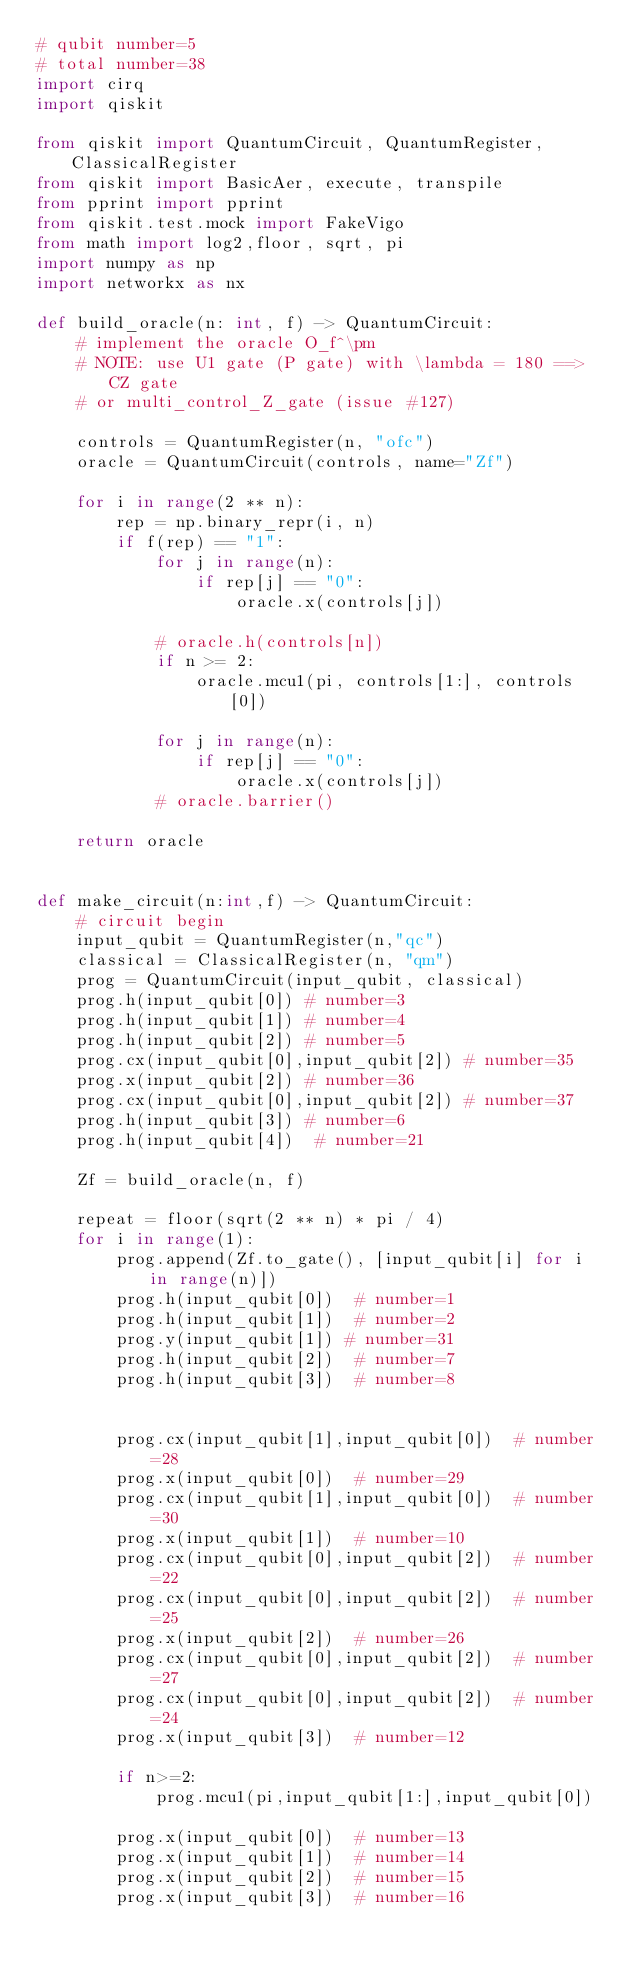Convert code to text. <code><loc_0><loc_0><loc_500><loc_500><_Python_># qubit number=5
# total number=38
import cirq
import qiskit

from qiskit import QuantumCircuit, QuantumRegister, ClassicalRegister
from qiskit import BasicAer, execute, transpile
from pprint import pprint
from qiskit.test.mock import FakeVigo
from math import log2,floor, sqrt, pi
import numpy as np
import networkx as nx

def build_oracle(n: int, f) -> QuantumCircuit:
    # implement the oracle O_f^\pm
    # NOTE: use U1 gate (P gate) with \lambda = 180 ==> CZ gate
    # or multi_control_Z_gate (issue #127)

    controls = QuantumRegister(n, "ofc")
    oracle = QuantumCircuit(controls, name="Zf")

    for i in range(2 ** n):
        rep = np.binary_repr(i, n)
        if f(rep) == "1":
            for j in range(n):
                if rep[j] == "0":
                    oracle.x(controls[j])

            # oracle.h(controls[n])
            if n >= 2:
                oracle.mcu1(pi, controls[1:], controls[0])

            for j in range(n):
                if rep[j] == "0":
                    oracle.x(controls[j])
            # oracle.barrier()

    return oracle


def make_circuit(n:int,f) -> QuantumCircuit:
    # circuit begin
    input_qubit = QuantumRegister(n,"qc")
    classical = ClassicalRegister(n, "qm")
    prog = QuantumCircuit(input_qubit, classical)
    prog.h(input_qubit[0]) # number=3
    prog.h(input_qubit[1]) # number=4
    prog.h(input_qubit[2]) # number=5
    prog.cx(input_qubit[0],input_qubit[2]) # number=35
    prog.x(input_qubit[2]) # number=36
    prog.cx(input_qubit[0],input_qubit[2]) # number=37
    prog.h(input_qubit[3]) # number=6
    prog.h(input_qubit[4])  # number=21

    Zf = build_oracle(n, f)

    repeat = floor(sqrt(2 ** n) * pi / 4)
    for i in range(1):
        prog.append(Zf.to_gate(), [input_qubit[i] for i in range(n)])
        prog.h(input_qubit[0])  # number=1
        prog.h(input_qubit[1])  # number=2
        prog.y(input_qubit[1]) # number=31
        prog.h(input_qubit[2])  # number=7
        prog.h(input_qubit[3])  # number=8


        prog.cx(input_qubit[1],input_qubit[0])  # number=28
        prog.x(input_qubit[0])  # number=29
        prog.cx(input_qubit[1],input_qubit[0])  # number=30
        prog.x(input_qubit[1])  # number=10
        prog.cx(input_qubit[0],input_qubit[2])  # number=22
        prog.cx(input_qubit[0],input_qubit[2])  # number=25
        prog.x(input_qubit[2])  # number=26
        prog.cx(input_qubit[0],input_qubit[2])  # number=27
        prog.cx(input_qubit[0],input_qubit[2])  # number=24
        prog.x(input_qubit[3])  # number=12

        if n>=2:
            prog.mcu1(pi,input_qubit[1:],input_qubit[0])

        prog.x(input_qubit[0])  # number=13
        prog.x(input_qubit[1])  # number=14
        prog.x(input_qubit[2])  # number=15
        prog.x(input_qubit[3])  # number=16

</code> 